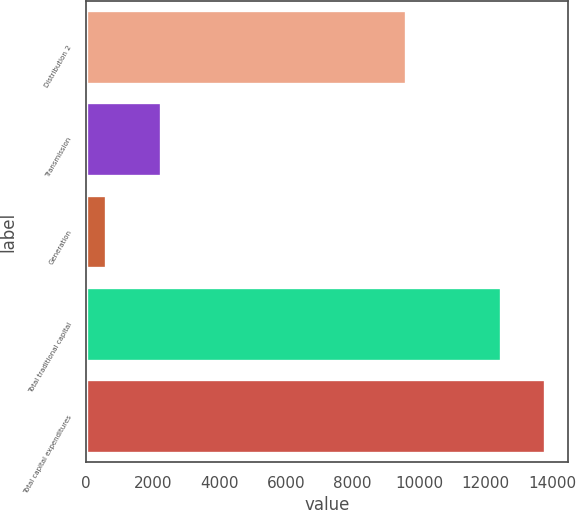Convert chart. <chart><loc_0><loc_0><loc_500><loc_500><bar_chart><fcel>Distribution 2<fcel>Transmission<fcel>Generation<fcel>Total traditional capital<fcel>Total capital expenditures<nl><fcel>9608<fcel>2245<fcel>606<fcel>12459<fcel>13770<nl></chart> 